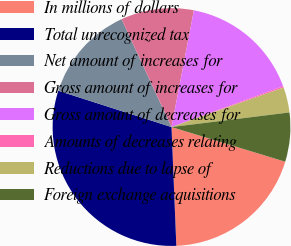<chart> <loc_0><loc_0><loc_500><loc_500><pie_chart><fcel>In millions of dollars<fcel>Total unrecognized tax<fcel>Net amount of increases for<fcel>Gross amount of increases for<fcel>Gross amount of decreases for<fcel>Amounts of decreases relating<fcel>Reductions due to lapse of<fcel>Foreign exchange acquisitions<nl><fcel>19.65%<fcel>30.59%<fcel>13.16%<fcel>9.92%<fcel>16.4%<fcel>0.19%<fcel>3.43%<fcel>6.67%<nl></chart> 